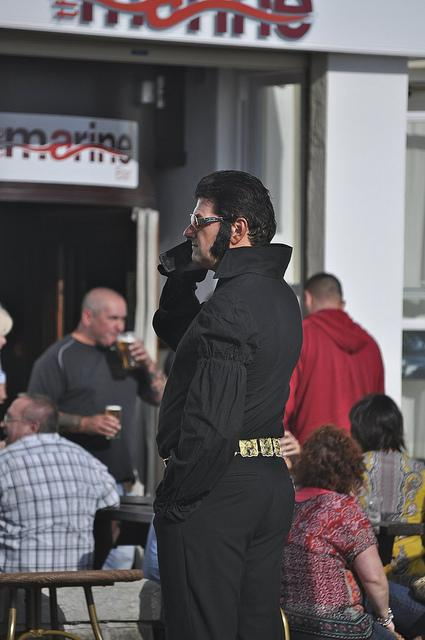The man in black is dressed like what star?

Choices:
A) john travolta
B) tom cruise
C) elvis
D) danny devito elvis 